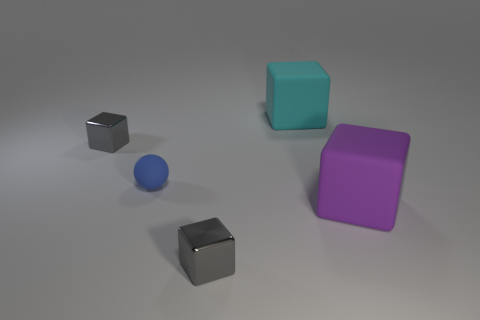Are there any spheres?
Provide a succinct answer. Yes. How many other objects are the same shape as the purple matte object?
Keep it short and to the point. 3. Is the color of the small metal cube in front of the small matte sphere the same as the rubber cube that is in front of the large cyan block?
Offer a very short reply. No. What is the size of the metallic block that is right of the metallic thing behind the tiny cube that is in front of the small rubber ball?
Your response must be concise. Small. The thing that is both to the left of the purple block and in front of the small blue sphere has what shape?
Keep it short and to the point. Cube. Is the number of tiny gray blocks left of the cyan object the same as the number of big purple rubber blocks that are behind the purple rubber block?
Provide a succinct answer. No. Are there any small gray cubes made of the same material as the tiny sphere?
Your answer should be compact. No. Are the big object that is on the right side of the large cyan object and the large cyan cube made of the same material?
Make the answer very short. Yes. What size is the rubber object that is both in front of the cyan object and left of the purple rubber object?
Offer a very short reply. Small. What color is the small ball?
Make the answer very short. Blue. 